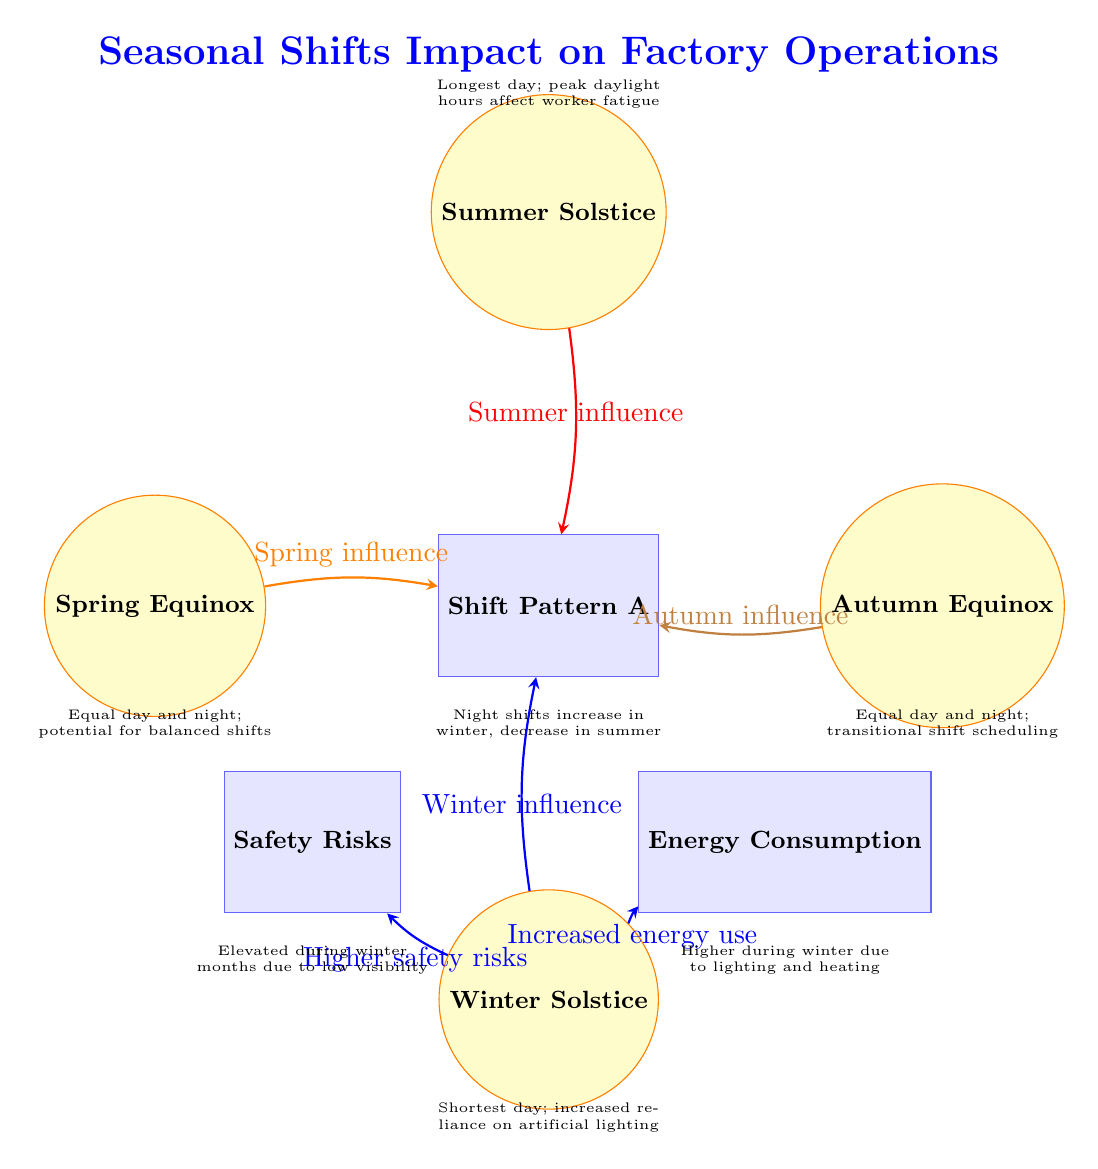What are the four celestial events illustrated in the diagram? The diagram shows four celestial events: Spring Equinox, Summer Solstice, Autumn Equinox, and Winter Solstice. Each event is placed in specific locations in relation to operational nodes, providing a clear visual reference.
Answer: Spring Equinox, Summer Solstice, Autumn Equinox, Winter Solstice Which operational node is influenced by the Summer Solstice? The Summer Solstice influences the Shift Pattern A operational node directly according to the arrow indicating this relationship.
Answer: Shift Pattern A How many operational nodes are in the diagram? There are a total of three operational nodes: Shift Pattern A, Energy Consumption, and Safety Risks. They are distinct rectangles connected to the celestial events through arrows.
Answer: 3 Which season shows an increase in energy consumption? The diagram indicates that Winter leads to increased energy use as shown by the thick blue arrow pointing from Winter Solstice to Energy Consumption.
Answer: Winter What is the relationship between Safety Risks and Winter? The diagram illustrates that Winter leads to higher safety risks, as indicated by the blue arrow linking Winter Solstice to the Safety Risks node. This indicates a direct causal link during winter months.
Answer: Higher safety risks 